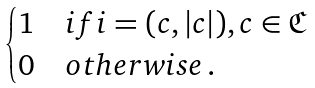<formula> <loc_0><loc_0><loc_500><loc_500>\begin{cases} 1 & i f i = ( c , | c | ) , c \in { \mathfrak C } \\ 0 & o t h e r w i s e \, . \end{cases}</formula> 